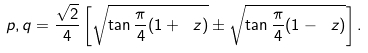<formula> <loc_0><loc_0><loc_500><loc_500>p , q = \frac { \sqrt { 2 } } { 4 } \left [ \sqrt { \tan \frac { \pi } { 4 } ( 1 + \ z ) } \pm \sqrt { \tan \frac { \pi } { 4 } ( 1 - \ z ) } \right ] .</formula> 